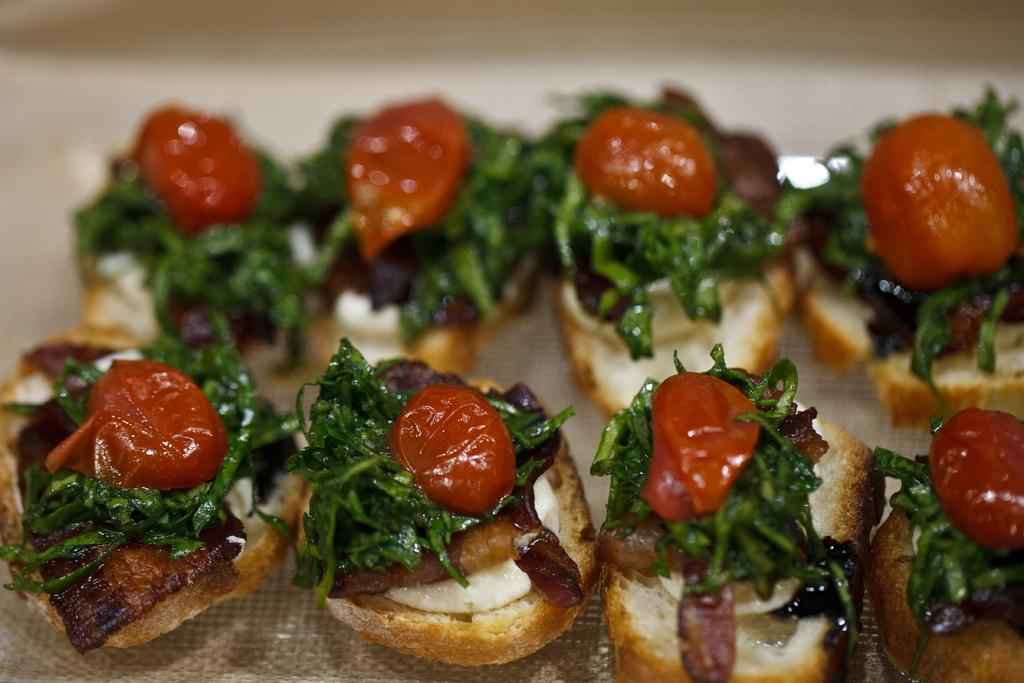What type of objects can be seen in the image? There are eatables in the image. Where might these eatables be placed? The eatables might be placed on a table. What is the color of the background in the image? The background of the image is white in color. How is the background of the image depicted? The background of the image is blurred. What type of hall can be seen in the image? There is no hall present in the image; it features eatables and a blurred white background. What is the desire of the eatables in the image? Eatables do not have desires, as they are inanimate objects. 